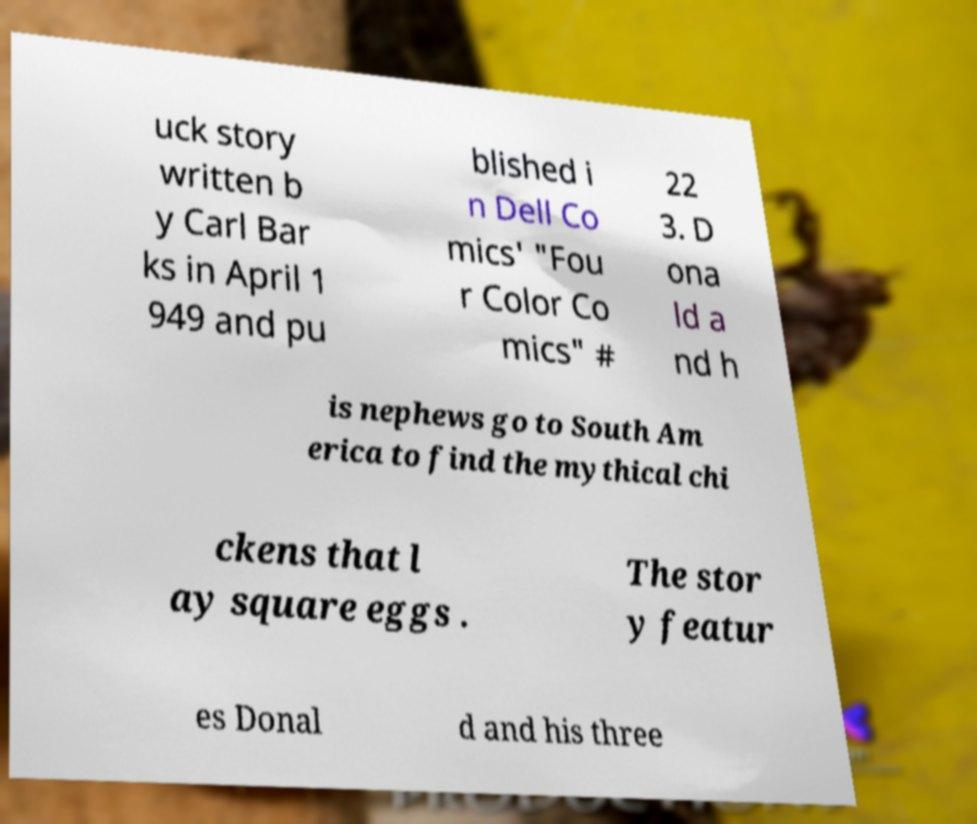For documentation purposes, I need the text within this image transcribed. Could you provide that? uck story written b y Carl Bar ks in April 1 949 and pu blished i n Dell Co mics' "Fou r Color Co mics" # 22 3. D ona ld a nd h is nephews go to South Am erica to find the mythical chi ckens that l ay square eggs . The stor y featur es Donal d and his three 